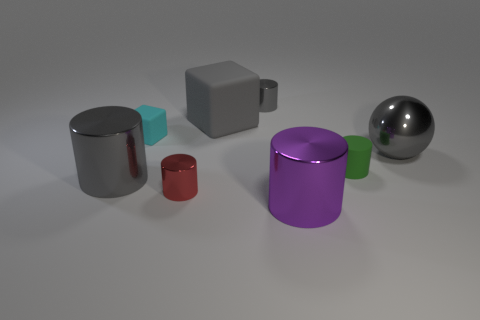Subtract 2 cylinders. How many cylinders are left? 3 Subtract all green cylinders. How many cylinders are left? 4 Subtract all big gray metallic cylinders. How many cylinders are left? 4 Subtract all brown cylinders. Subtract all yellow blocks. How many cylinders are left? 5 Add 2 big gray cylinders. How many objects exist? 10 Subtract all spheres. How many objects are left? 7 Add 2 large shiny balls. How many large shiny balls are left? 3 Add 5 large metallic cylinders. How many large metallic cylinders exist? 7 Subtract 0 purple cubes. How many objects are left? 8 Subtract all large cubes. Subtract all big gray metal spheres. How many objects are left? 6 